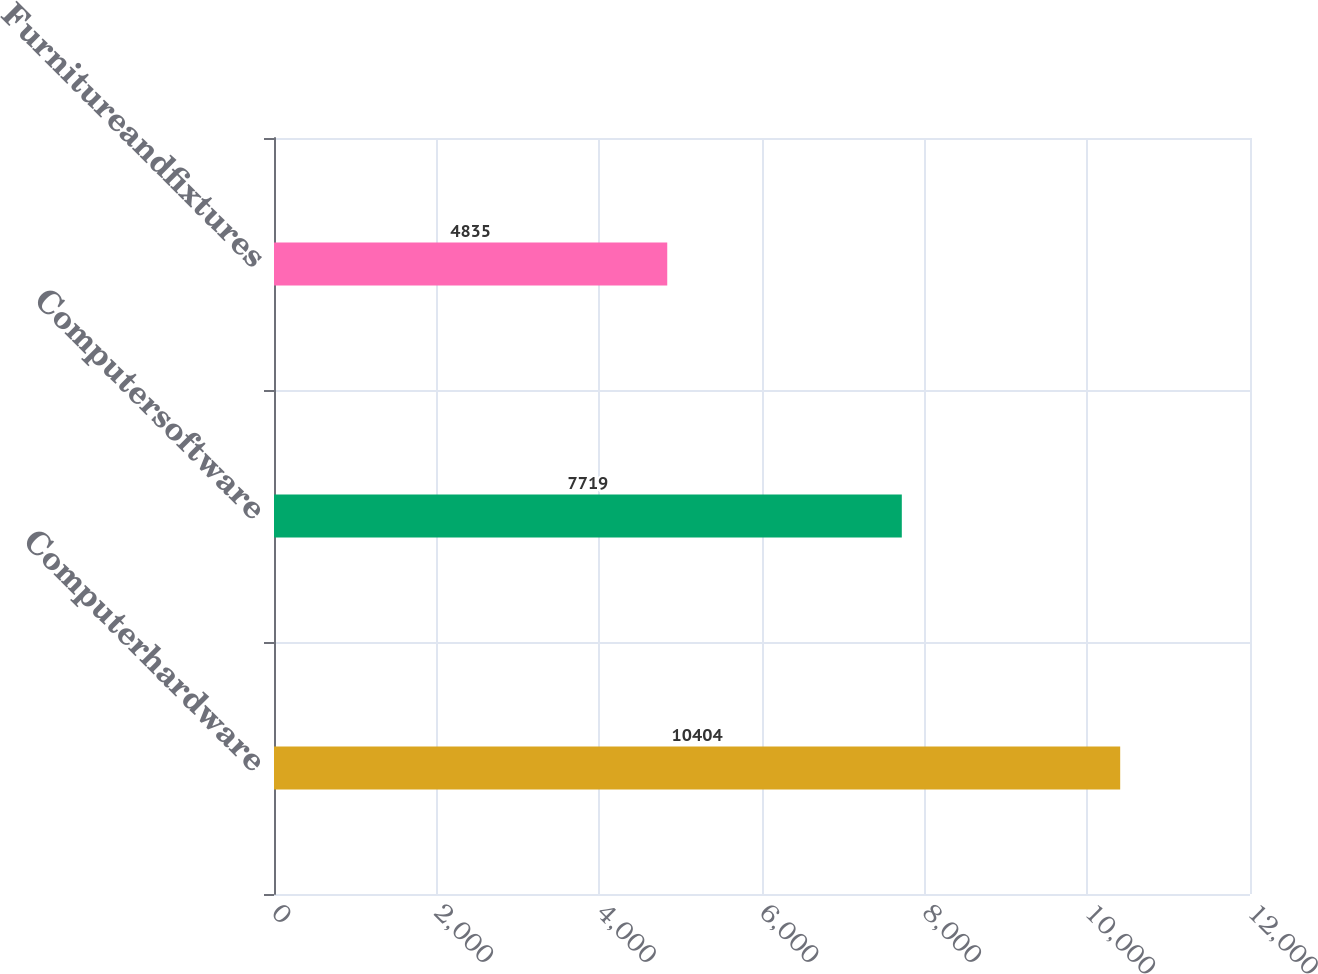<chart> <loc_0><loc_0><loc_500><loc_500><bar_chart><fcel>Computerhardware<fcel>Computersoftware<fcel>Furnitureandfixtures<nl><fcel>10404<fcel>7719<fcel>4835<nl></chart> 